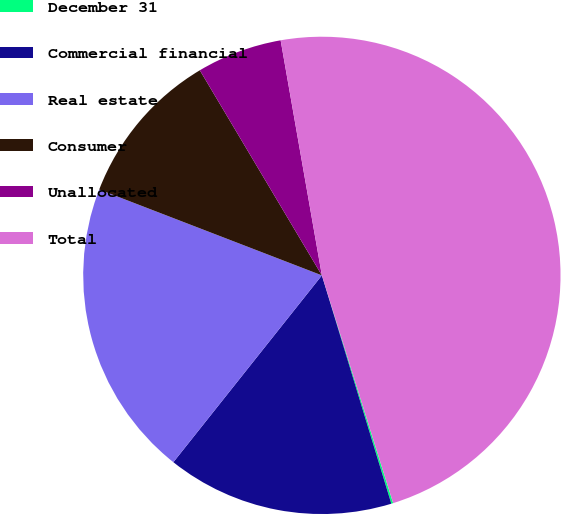Convert chart. <chart><loc_0><loc_0><loc_500><loc_500><pie_chart><fcel>December 31<fcel>Commercial financial<fcel>Real estate<fcel>Consumer<fcel>Unallocated<fcel>Total<nl><fcel>0.13%<fcel>15.39%<fcel>20.17%<fcel>10.6%<fcel>5.78%<fcel>47.94%<nl></chart> 